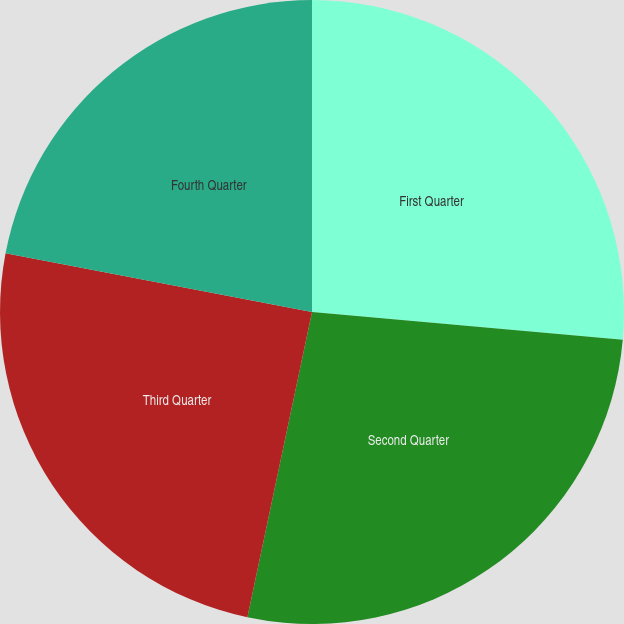Convert chart to OTSL. <chart><loc_0><loc_0><loc_500><loc_500><pie_chart><fcel>First Quarter<fcel>Second Quarter<fcel>Third Quarter<fcel>Fourth Quarter<nl><fcel>26.42%<fcel>26.9%<fcel>24.69%<fcel>21.99%<nl></chart> 